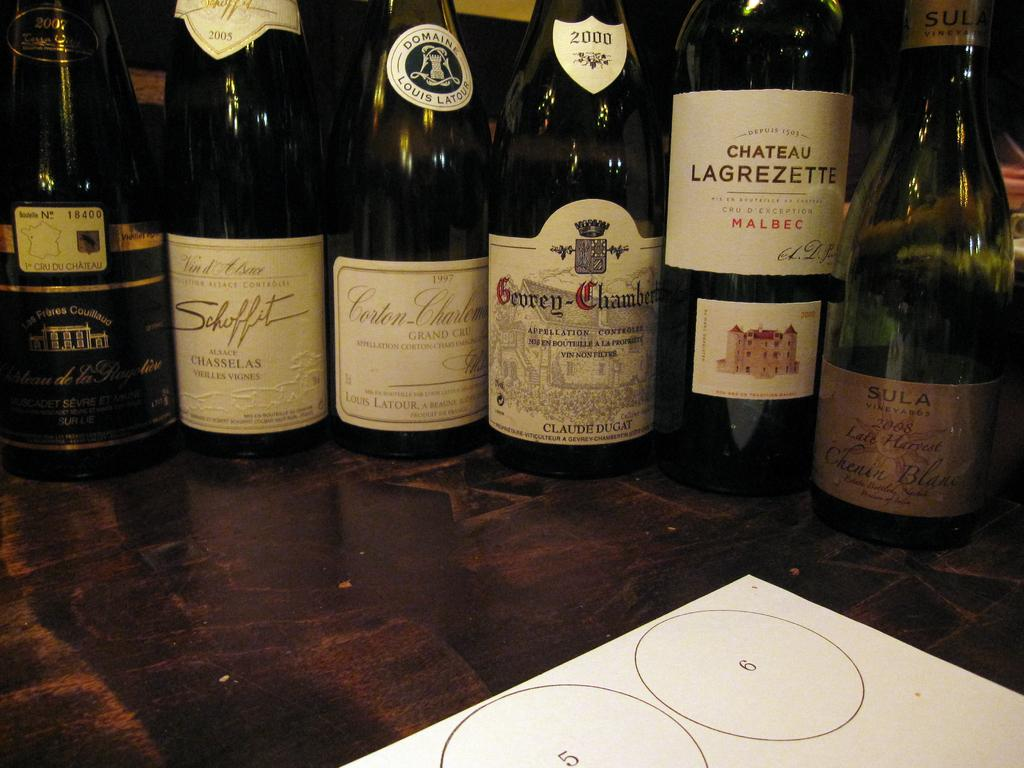Provide a one-sentence caption for the provided image. Wine bottles placed next to one another with Chateau Lagrezette being the first. 